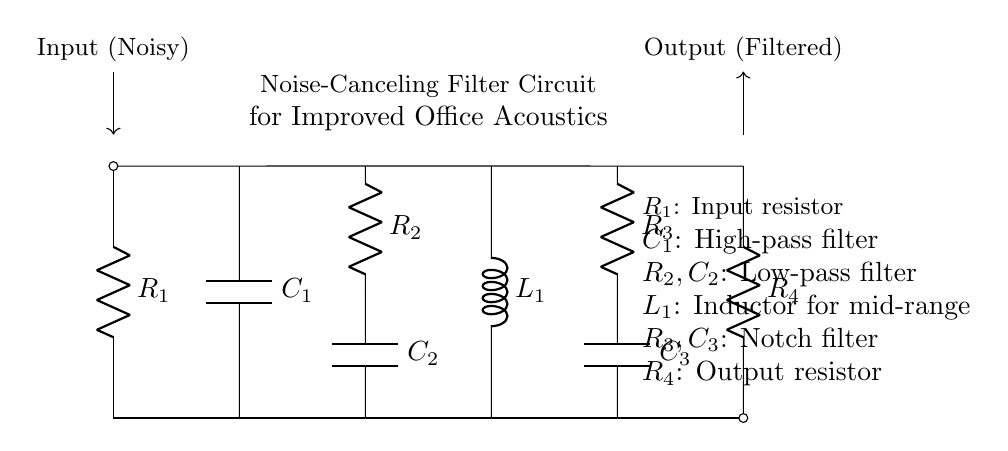What is the purpose of the input resistor? The input resistor, labeled as R1, is used to limit the current entering the circuit and to establish the input voltage level for the subsequent filtering components.
Answer: Input resistor What type of filter is represented by R2 and C2? R2 and C2 form a low-pass filter, which allows low-frequency signals to pass while attenuating higher frequencies. This is crucial for removing unwanted high-frequency noise.
Answer: Low-pass filter How many capacitors are in this circuit? There are three capacitors in the circuit, denoted as C1, C2, and C3. Each capacitor plays a specific role in the overall filtering process of different frequency ranges.
Answer: Three What component is used for mid-range filtering? The inductor, labeled as L1, is used for mid-range frequency filtering in this circuit. It helps to manage the impedance in the mid-range, improving noise cancellation.
Answer: Inductor What is the output component of the circuit? The output component is the output resistor, labeled as R4, which is designed to provide a load to the filtered signal before it exits the circuit, ensuring optimal operation.
Answer: Output resistor What does the configuration with R3 and C3 represent? The combination of R3 and C3 forms a notch filter, which is specifically used to reduce or eliminate a narrow band of frequencies, thereby effectively canceling out specific unwanted noise.
Answer: Notch filter What is the role of the capacitor C1? Capacitor C1 is a high-pass filter, which allows high-frequency signals to pass through while blocking lower frequency noise, thereby contributing to the overall acoustic enhancement of the workspace.
Answer: High-pass filter 